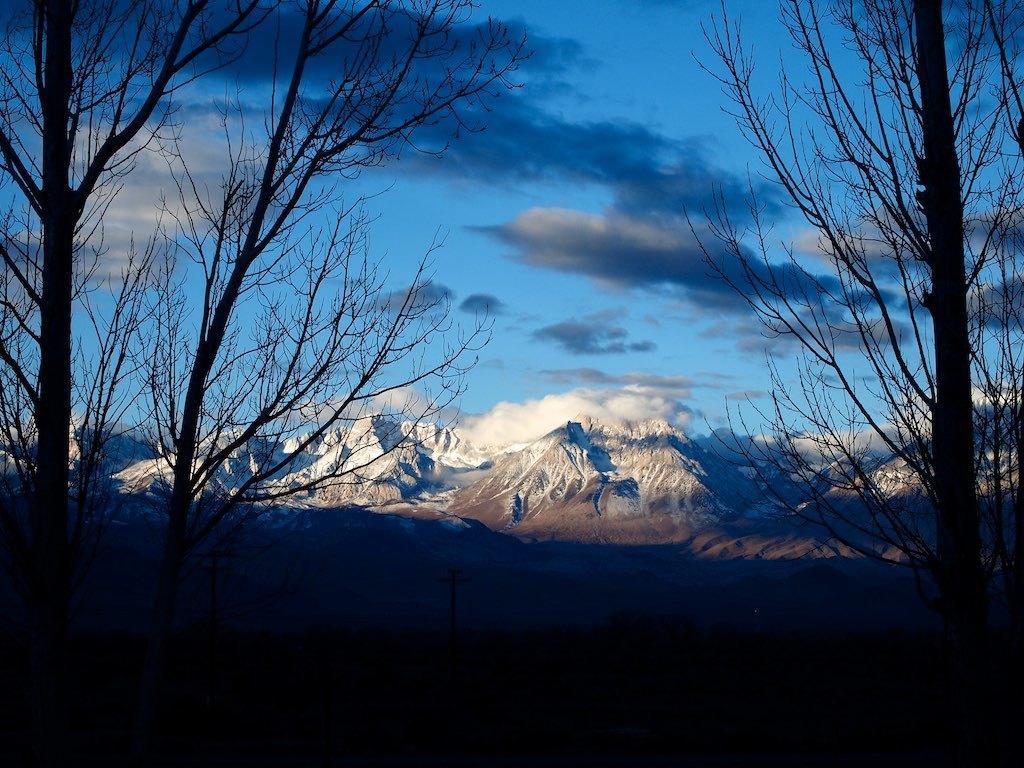In one or two sentences, can you explain what this image depicts? In this image at the bottom there is walkway and also we could see trees and and some rods, and in the background there are mountains and sand. At the top of the image there is sky. 